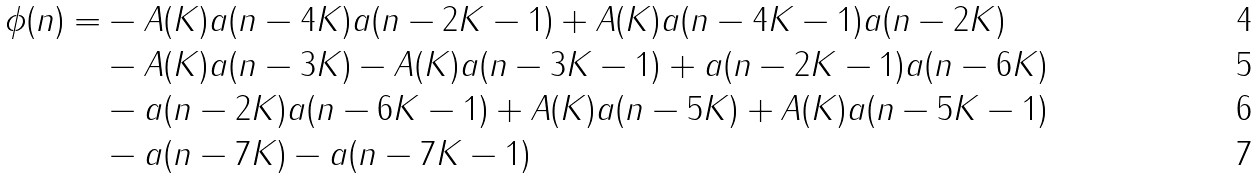Convert formula to latex. <formula><loc_0><loc_0><loc_500><loc_500>\phi ( n ) = & - A ( K ) a ( n - 4 K ) a ( n - 2 K - 1 ) + A ( K ) a ( n - 4 K - 1 ) a ( n - 2 K ) \\ & - A ( K ) a ( n - 3 K ) - A ( K ) a ( n - 3 K - 1 ) + a ( n - 2 K - 1 ) a ( n - 6 K ) \\ & - a ( n - 2 K ) a ( n - 6 K - 1 ) + A ( K ) a ( n - 5 K ) + A ( K ) a ( n - 5 K - 1 ) \\ & - a ( n - 7 K ) - a ( n - 7 K - 1 )</formula> 